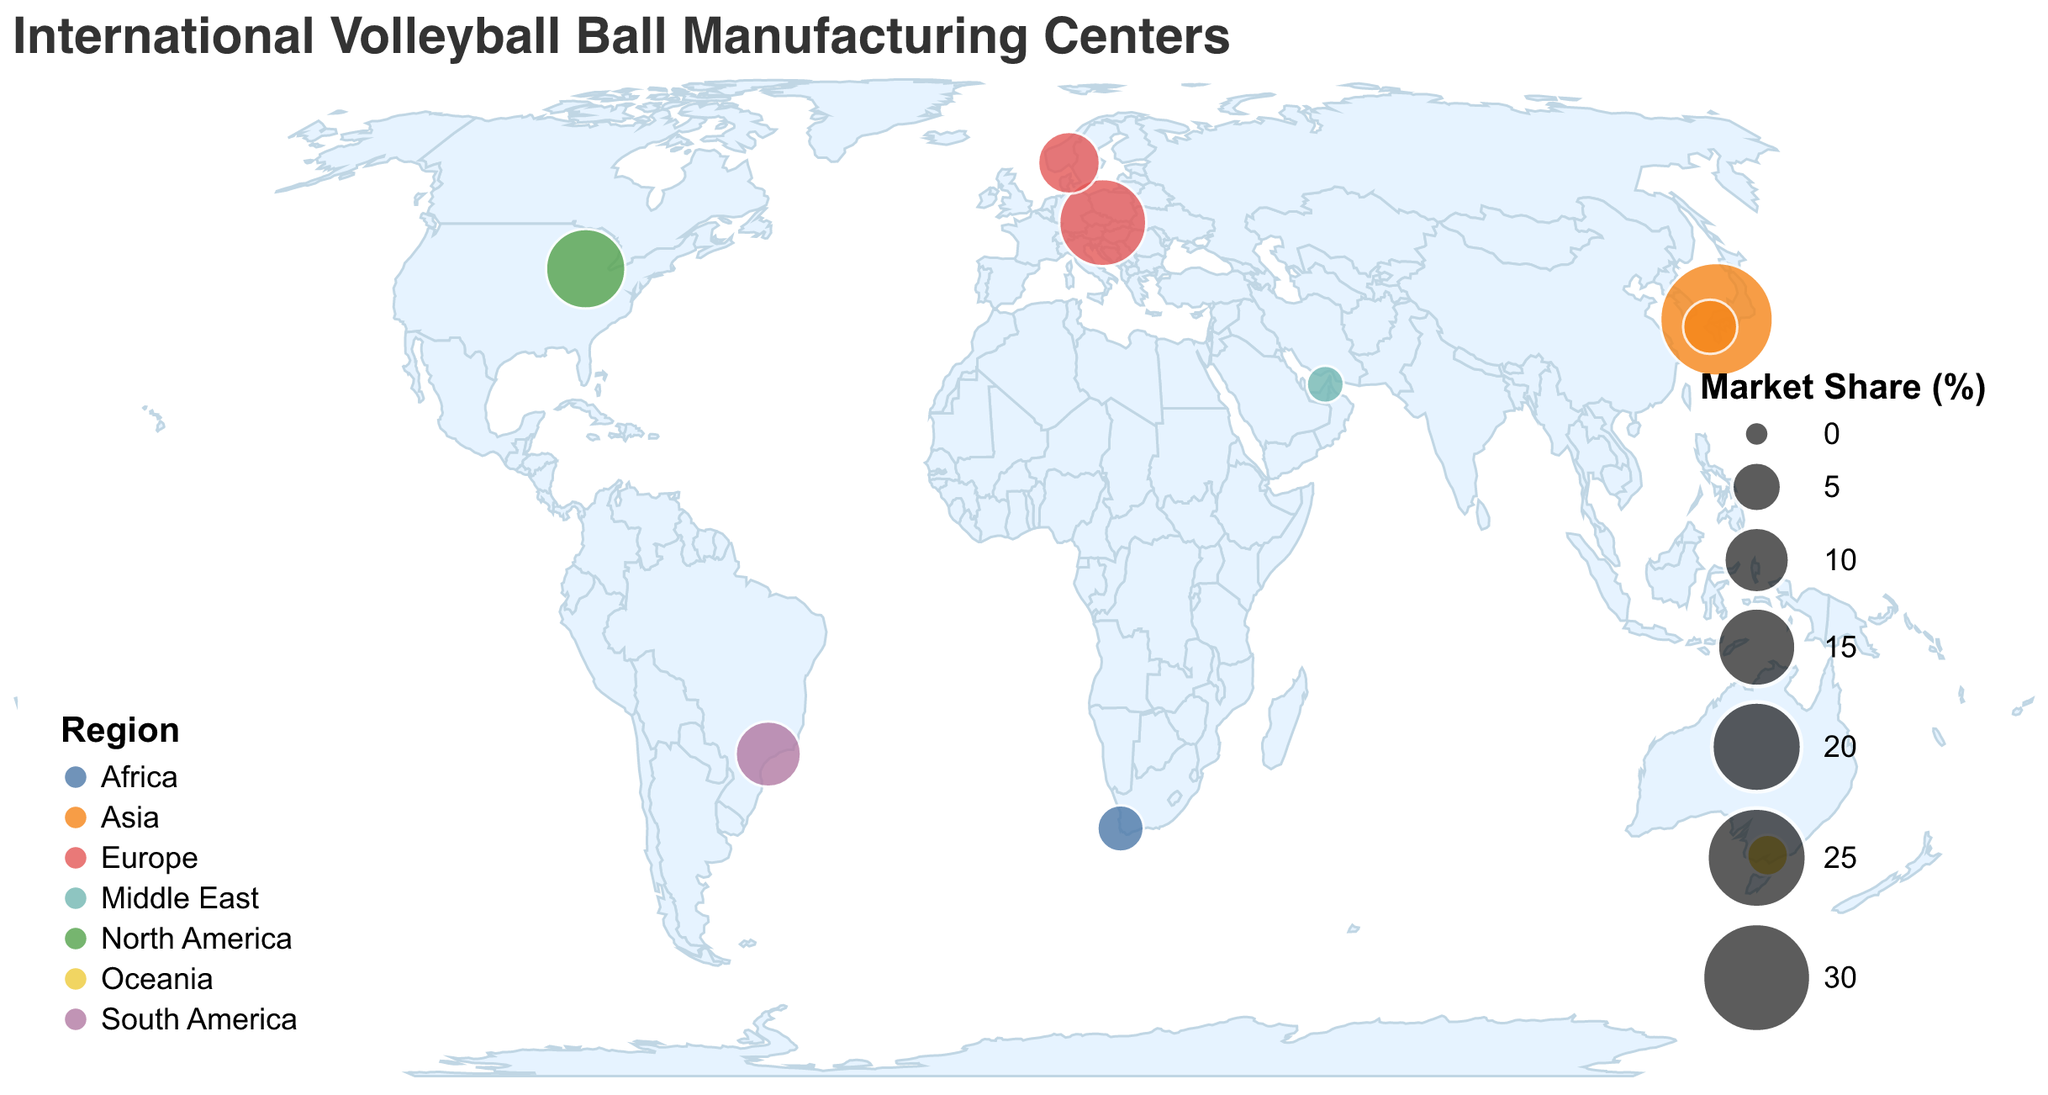What's the title of the figure? The title of the figure is located at the top and clearly mentions the subject of the visualization.
Answer: International Volleyball Ball Manufacturing Centers Which region has the highest market share? The market share is indicated by the size of the circles, and from the figure, the largest circle is in Asia.
Answer: Asia How many manufacturers are located in Europe? To determine this, we look at the circles color-coded for Europe in the legend, which indicates there are 2 data points.
Answer: 2 Which manufacturer in North America has the largest market share, and what is the value? Look for the circle in North America and check the tooltip or legend information associated with it. The manufacturer with the largest share, as shown by the largest circle, is Wilson with 15.3%.
Answer: Wilson, 15.3% What is the combined market share of Mikasa and Tachikara? Find the market shares of Mikasa and Tachikara in Japan and sum them up. Mikasa has 32.5%, and Tachikara has 6.2%. So, the combined share is 32.5% + 6.2% = 38.7%.
Answer: 38.7% Which region has the lowest market share, and what is the value? Identify the smallest circle using the figure and the legend. The smallest circle is in the Middle East with 2.0%.
Answer: Middle East, 2.0% Compare the market share of the Asia region to the Europe region. Which is larger and by how much? Sum the market shares of both manufacturers in each region. Asia: 32.5% + 6.2% = 38.7%, Europe: 18.7% + 8.6% = 27.3%. Thus, the difference is 38.7% - 27.3% = 11.4%.
Answer: Asia is larger by 11.4% What's the total market share covered by all regions combined? Sum up the market shares of all manufacturers: 32.5% + 18.7% + 15.3% + 9.8% + 8.6% + 6.2% + 4.1% + 2.8% + 2.0% = 100%.
Answer: 100% What is the color used to represent Africa in the figure? Refer to the legend that associates regions with specific colors. The color for Africa is found there.
Answer: the color used for Africa is specific to the visualization scheme used, such as a shade from the tableau10 color scheme Identify which manufacturer has its facility located in Melbourne, Australia, and find its market share. Match the city's name to its corresponding data point. Melbourne, Australia, is represented by Kaepa, with a market share of 2.8%.
Answer: Kaepa, 2.8% 